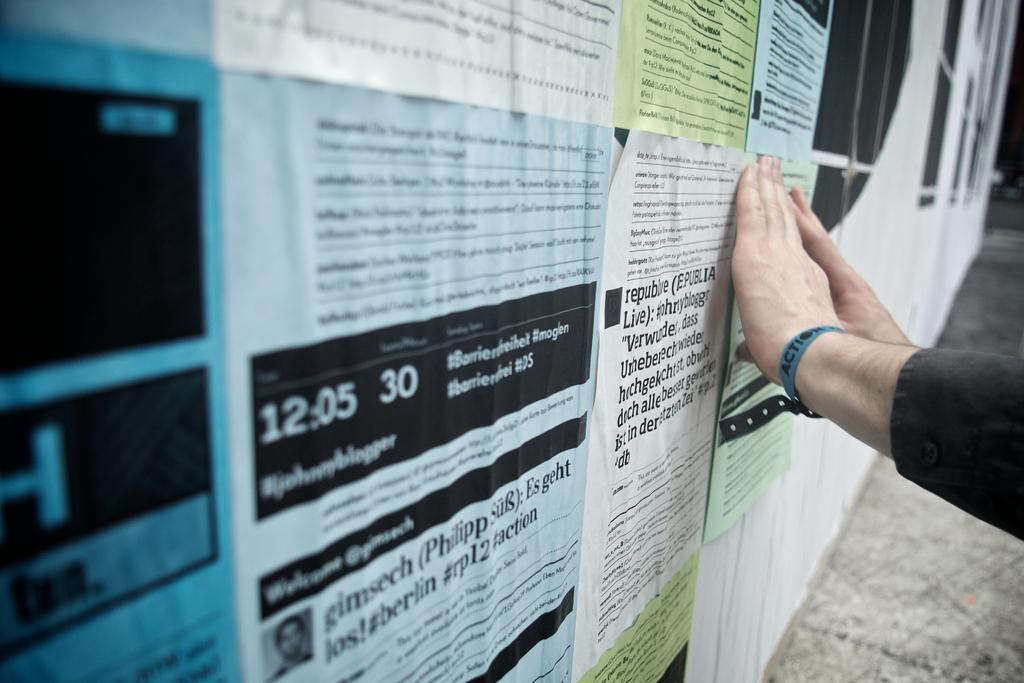<image>
Render a clear and concise summary of the photo. Bulletin board with flyers and one says the time of 12:05 